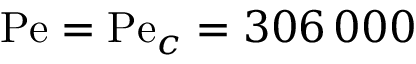<formula> <loc_0><loc_0><loc_500><loc_500>P e = P e _ { c } = 3 0 6 \, 0 0 0</formula> 